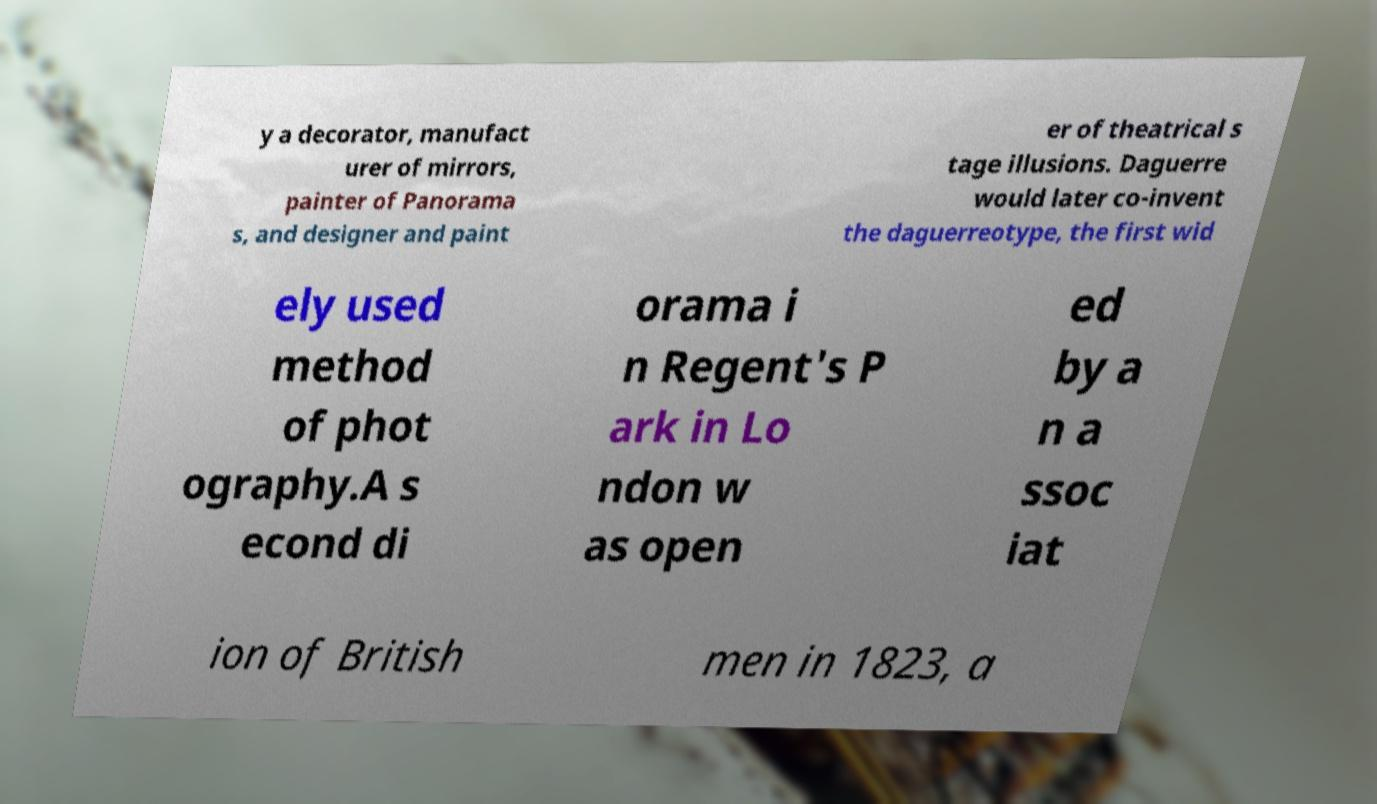For documentation purposes, I need the text within this image transcribed. Could you provide that? y a decorator, manufact urer of mirrors, painter of Panorama s, and designer and paint er of theatrical s tage illusions. Daguerre would later co-invent the daguerreotype, the first wid ely used method of phot ography.A s econd di orama i n Regent's P ark in Lo ndon w as open ed by a n a ssoc iat ion of British men in 1823, a 